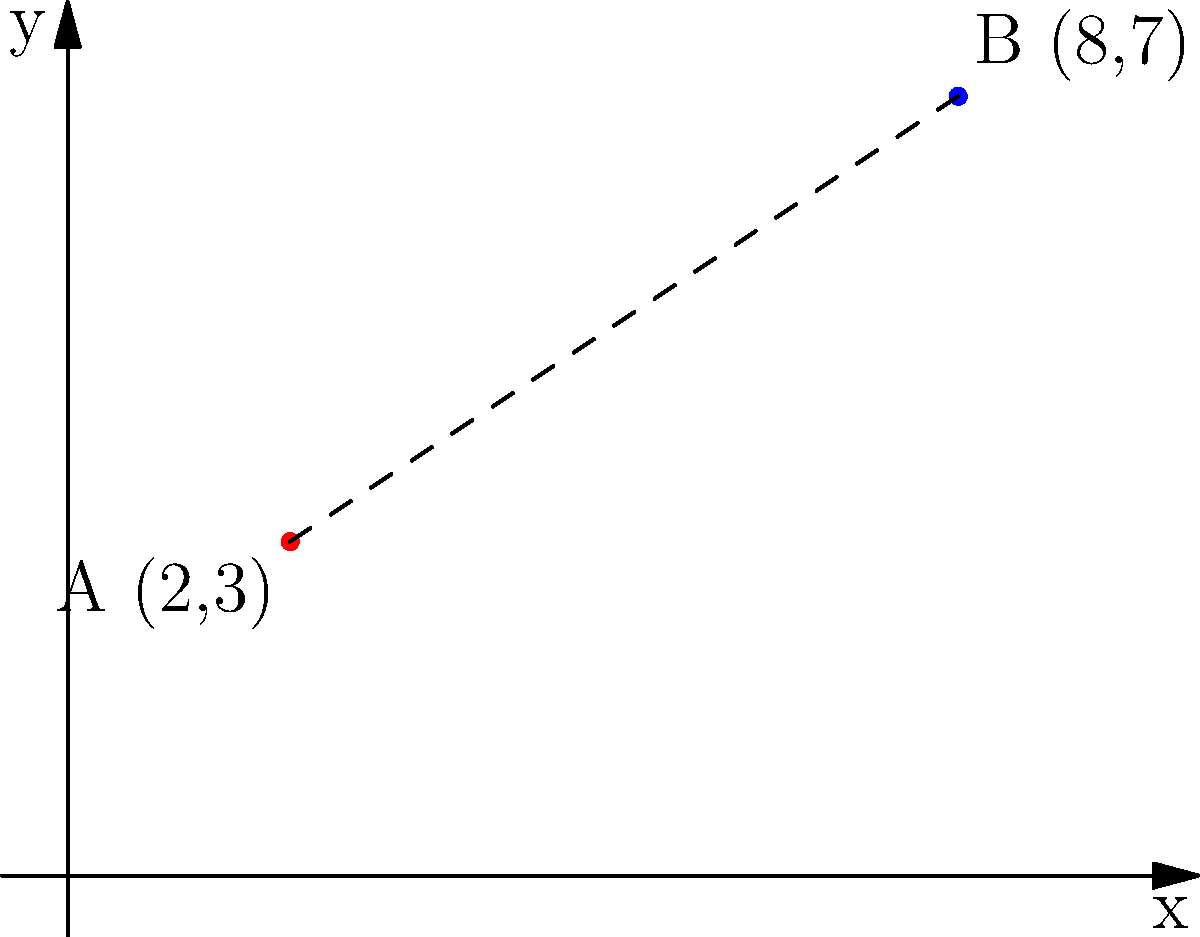As a corporate lobbyist, you're analyzing the distance between two data storage locations to argue against stringent data protection laws. Given two storage points A(2,3) and B(8,7) on a coordinate plane representing different jurisdictions, calculate the distance between these points. How does this distance support your argument for more lenient cross-border data transfer regulations? To calculate the distance between two points, we use the distance formula derived from the Pythagorean theorem:

$$d = \sqrt{(x_2 - x_1)^2 + (y_2 - y_1)^2}$$

Where $(x_1, y_1)$ is the coordinate of point A and $(x_2, y_2)$ is the coordinate of point B.

Step 1: Identify the coordinates
A(2,3) and B(8,7)

Step 2: Plug the values into the formula
$$d = \sqrt{(8 - 2)^2 + (7 - 3)^2}$$

Step 3: Simplify inside the parentheses
$$d = \sqrt{6^2 + 4^2}$$

Step 4: Calculate the squares
$$d = \sqrt{36 + 16}$$

Step 5: Add under the square root
$$d = \sqrt{52}$$

Step 6: Simplify the square root
$$d = 2\sqrt{13} \approx 7.21$$

The distance between the two points is $2\sqrt{13}$ units or approximately 7.21 units.

This relatively short distance can be used to argue that even data storage locations in different jurisdictions can be geographically close. Therefore, stringent cross-border data transfer regulations may be unnecessary and could hinder efficient business operations. The lobbyist could argue that this proximity demonstrates the interconnectedness of modern data systems and the need for more flexible, business-friendly data protection laws that allow for easier data transfer between nearby locations, regardless of jurisdictional boundaries.
Answer: $2\sqrt{13}$ units 